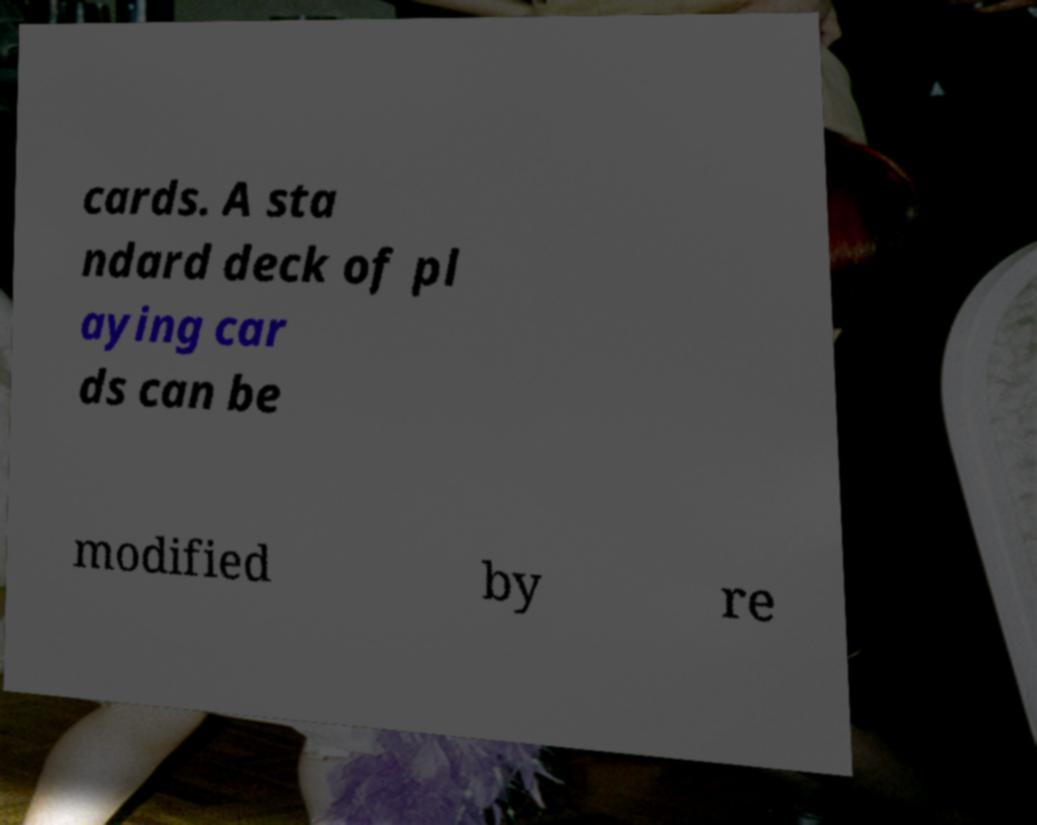Can you accurately transcribe the text from the provided image for me? cards. A sta ndard deck of pl aying car ds can be modified by re 